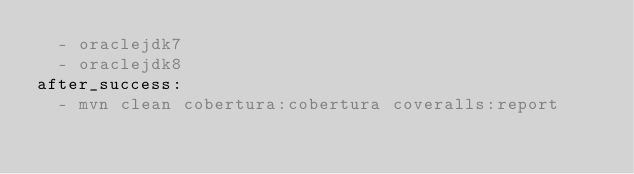Convert code to text. <code><loc_0><loc_0><loc_500><loc_500><_YAML_>  - oraclejdk7
  - oraclejdk8
after_success:
  - mvn clean cobertura:cobertura coveralls:report</code> 